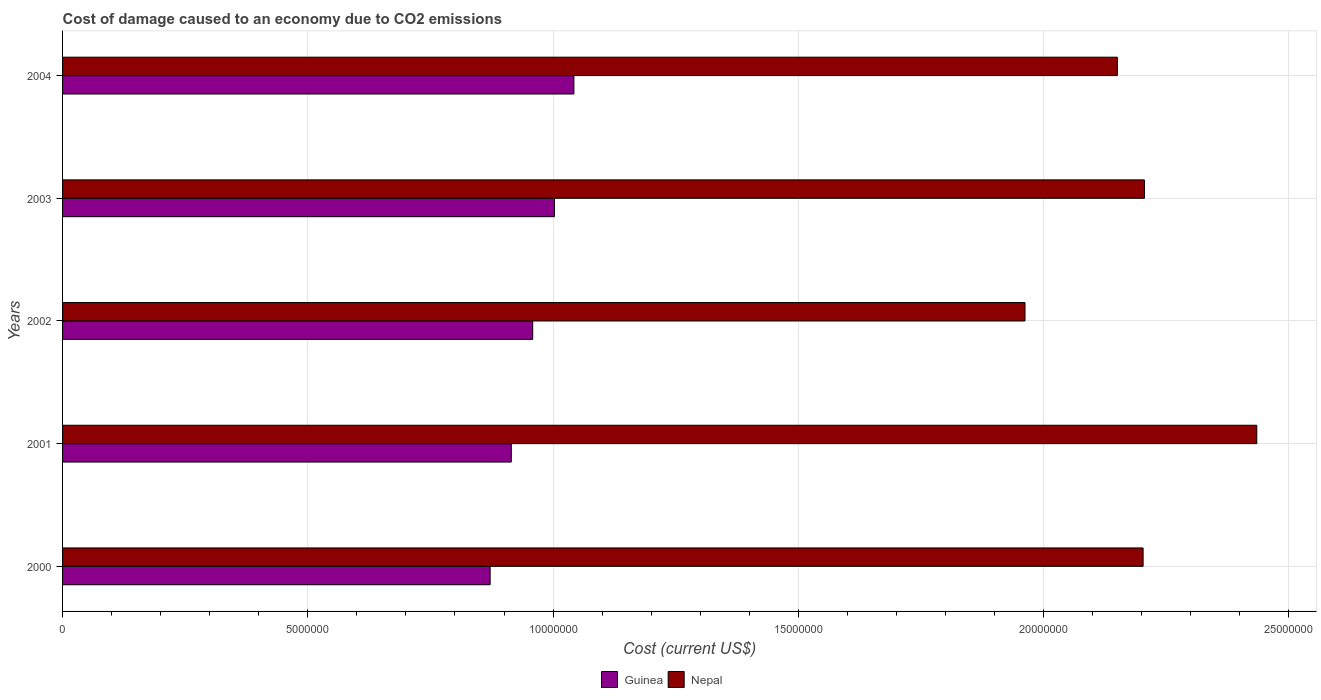How many different coloured bars are there?
Provide a succinct answer. 2. How many groups of bars are there?
Your answer should be very brief. 5. How many bars are there on the 2nd tick from the top?
Your response must be concise. 2. What is the label of the 2nd group of bars from the top?
Give a very brief answer. 2003. What is the cost of damage caused due to CO2 emissisons in Nepal in 2004?
Make the answer very short. 2.15e+07. Across all years, what is the maximum cost of damage caused due to CO2 emissisons in Nepal?
Provide a succinct answer. 2.43e+07. Across all years, what is the minimum cost of damage caused due to CO2 emissisons in Nepal?
Your answer should be compact. 1.96e+07. In which year was the cost of damage caused due to CO2 emissisons in Guinea maximum?
Your response must be concise. 2004. In which year was the cost of damage caused due to CO2 emissisons in Guinea minimum?
Your answer should be very brief. 2000. What is the total cost of damage caused due to CO2 emissisons in Nepal in the graph?
Keep it short and to the point. 1.10e+08. What is the difference between the cost of damage caused due to CO2 emissisons in Guinea in 2002 and that in 2004?
Offer a terse response. -8.40e+05. What is the difference between the cost of damage caused due to CO2 emissisons in Guinea in 2000 and the cost of damage caused due to CO2 emissisons in Nepal in 2001?
Your response must be concise. -1.56e+07. What is the average cost of damage caused due to CO2 emissisons in Nepal per year?
Keep it short and to the point. 2.19e+07. In the year 2002, what is the difference between the cost of damage caused due to CO2 emissisons in Guinea and cost of damage caused due to CO2 emissisons in Nepal?
Keep it short and to the point. -1.00e+07. In how many years, is the cost of damage caused due to CO2 emissisons in Nepal greater than 13000000 US$?
Ensure brevity in your answer.  5. What is the ratio of the cost of damage caused due to CO2 emissisons in Guinea in 2001 to that in 2004?
Your answer should be compact. 0.88. What is the difference between the highest and the second highest cost of damage caused due to CO2 emissisons in Guinea?
Make the answer very short. 3.97e+05. What is the difference between the highest and the lowest cost of damage caused due to CO2 emissisons in Guinea?
Offer a terse response. 1.71e+06. What does the 1st bar from the top in 2002 represents?
Provide a short and direct response. Nepal. What does the 2nd bar from the bottom in 2001 represents?
Your response must be concise. Nepal. Are all the bars in the graph horizontal?
Make the answer very short. Yes. What is the difference between two consecutive major ticks on the X-axis?
Make the answer very short. 5.00e+06. Are the values on the major ticks of X-axis written in scientific E-notation?
Your answer should be very brief. No. Does the graph contain any zero values?
Give a very brief answer. No. Where does the legend appear in the graph?
Give a very brief answer. Bottom center. What is the title of the graph?
Offer a very short reply. Cost of damage caused to an economy due to CO2 emissions. Does "Monaco" appear as one of the legend labels in the graph?
Ensure brevity in your answer.  No. What is the label or title of the X-axis?
Give a very brief answer. Cost (current US$). What is the label or title of the Y-axis?
Offer a very short reply. Years. What is the Cost (current US$) of Guinea in 2000?
Offer a very short reply. 8.72e+06. What is the Cost (current US$) in Nepal in 2000?
Your answer should be very brief. 2.20e+07. What is the Cost (current US$) in Guinea in 2001?
Make the answer very short. 9.15e+06. What is the Cost (current US$) in Nepal in 2001?
Keep it short and to the point. 2.43e+07. What is the Cost (current US$) of Guinea in 2002?
Provide a succinct answer. 9.58e+06. What is the Cost (current US$) in Nepal in 2002?
Offer a very short reply. 1.96e+07. What is the Cost (current US$) in Guinea in 2003?
Your answer should be compact. 1.00e+07. What is the Cost (current US$) of Nepal in 2003?
Ensure brevity in your answer.  2.21e+07. What is the Cost (current US$) in Guinea in 2004?
Offer a very short reply. 1.04e+07. What is the Cost (current US$) of Nepal in 2004?
Offer a very short reply. 2.15e+07. Across all years, what is the maximum Cost (current US$) of Guinea?
Offer a very short reply. 1.04e+07. Across all years, what is the maximum Cost (current US$) in Nepal?
Offer a very short reply. 2.43e+07. Across all years, what is the minimum Cost (current US$) in Guinea?
Make the answer very short. 8.72e+06. Across all years, what is the minimum Cost (current US$) of Nepal?
Your answer should be very brief. 1.96e+07. What is the total Cost (current US$) in Guinea in the graph?
Your response must be concise. 4.79e+07. What is the total Cost (current US$) of Nepal in the graph?
Your answer should be compact. 1.10e+08. What is the difference between the Cost (current US$) of Guinea in 2000 and that in 2001?
Keep it short and to the point. -4.33e+05. What is the difference between the Cost (current US$) of Nepal in 2000 and that in 2001?
Make the answer very short. -2.32e+06. What is the difference between the Cost (current US$) of Guinea in 2000 and that in 2002?
Provide a succinct answer. -8.68e+05. What is the difference between the Cost (current US$) of Nepal in 2000 and that in 2002?
Offer a terse response. 2.41e+06. What is the difference between the Cost (current US$) of Guinea in 2000 and that in 2003?
Keep it short and to the point. -1.31e+06. What is the difference between the Cost (current US$) of Nepal in 2000 and that in 2003?
Provide a succinct answer. -2.67e+04. What is the difference between the Cost (current US$) in Guinea in 2000 and that in 2004?
Give a very brief answer. -1.71e+06. What is the difference between the Cost (current US$) of Nepal in 2000 and that in 2004?
Make the answer very short. 5.25e+05. What is the difference between the Cost (current US$) of Guinea in 2001 and that in 2002?
Give a very brief answer. -4.36e+05. What is the difference between the Cost (current US$) in Nepal in 2001 and that in 2002?
Keep it short and to the point. 4.73e+06. What is the difference between the Cost (current US$) of Guinea in 2001 and that in 2003?
Make the answer very short. -8.79e+05. What is the difference between the Cost (current US$) of Nepal in 2001 and that in 2003?
Keep it short and to the point. 2.29e+06. What is the difference between the Cost (current US$) in Guinea in 2001 and that in 2004?
Make the answer very short. -1.28e+06. What is the difference between the Cost (current US$) of Nepal in 2001 and that in 2004?
Your answer should be compact. 2.84e+06. What is the difference between the Cost (current US$) of Guinea in 2002 and that in 2003?
Offer a very short reply. -4.43e+05. What is the difference between the Cost (current US$) in Nepal in 2002 and that in 2003?
Your answer should be very brief. -2.43e+06. What is the difference between the Cost (current US$) in Guinea in 2002 and that in 2004?
Offer a terse response. -8.40e+05. What is the difference between the Cost (current US$) in Nepal in 2002 and that in 2004?
Offer a very short reply. -1.88e+06. What is the difference between the Cost (current US$) of Guinea in 2003 and that in 2004?
Provide a short and direct response. -3.97e+05. What is the difference between the Cost (current US$) of Nepal in 2003 and that in 2004?
Give a very brief answer. 5.52e+05. What is the difference between the Cost (current US$) in Guinea in 2000 and the Cost (current US$) in Nepal in 2001?
Your answer should be compact. -1.56e+07. What is the difference between the Cost (current US$) of Guinea in 2000 and the Cost (current US$) of Nepal in 2002?
Give a very brief answer. -1.09e+07. What is the difference between the Cost (current US$) in Guinea in 2000 and the Cost (current US$) in Nepal in 2003?
Ensure brevity in your answer.  -1.33e+07. What is the difference between the Cost (current US$) in Guinea in 2000 and the Cost (current US$) in Nepal in 2004?
Your answer should be very brief. -1.28e+07. What is the difference between the Cost (current US$) of Guinea in 2001 and the Cost (current US$) of Nepal in 2002?
Provide a short and direct response. -1.05e+07. What is the difference between the Cost (current US$) in Guinea in 2001 and the Cost (current US$) in Nepal in 2003?
Your answer should be very brief. -1.29e+07. What is the difference between the Cost (current US$) in Guinea in 2001 and the Cost (current US$) in Nepal in 2004?
Keep it short and to the point. -1.24e+07. What is the difference between the Cost (current US$) in Guinea in 2002 and the Cost (current US$) in Nepal in 2003?
Give a very brief answer. -1.25e+07. What is the difference between the Cost (current US$) of Guinea in 2002 and the Cost (current US$) of Nepal in 2004?
Ensure brevity in your answer.  -1.19e+07. What is the difference between the Cost (current US$) of Guinea in 2003 and the Cost (current US$) of Nepal in 2004?
Provide a succinct answer. -1.15e+07. What is the average Cost (current US$) in Guinea per year?
Ensure brevity in your answer.  9.58e+06. What is the average Cost (current US$) in Nepal per year?
Offer a very short reply. 2.19e+07. In the year 2000, what is the difference between the Cost (current US$) in Guinea and Cost (current US$) in Nepal?
Provide a short and direct response. -1.33e+07. In the year 2001, what is the difference between the Cost (current US$) in Guinea and Cost (current US$) in Nepal?
Offer a terse response. -1.52e+07. In the year 2002, what is the difference between the Cost (current US$) of Guinea and Cost (current US$) of Nepal?
Provide a short and direct response. -1.00e+07. In the year 2003, what is the difference between the Cost (current US$) in Guinea and Cost (current US$) in Nepal?
Your answer should be compact. -1.20e+07. In the year 2004, what is the difference between the Cost (current US$) in Guinea and Cost (current US$) in Nepal?
Offer a very short reply. -1.11e+07. What is the ratio of the Cost (current US$) of Guinea in 2000 to that in 2001?
Make the answer very short. 0.95. What is the ratio of the Cost (current US$) in Nepal in 2000 to that in 2001?
Offer a very short reply. 0.9. What is the ratio of the Cost (current US$) of Guinea in 2000 to that in 2002?
Provide a short and direct response. 0.91. What is the ratio of the Cost (current US$) in Nepal in 2000 to that in 2002?
Ensure brevity in your answer.  1.12. What is the ratio of the Cost (current US$) in Guinea in 2000 to that in 2003?
Keep it short and to the point. 0.87. What is the ratio of the Cost (current US$) of Nepal in 2000 to that in 2003?
Offer a very short reply. 1. What is the ratio of the Cost (current US$) in Guinea in 2000 to that in 2004?
Your answer should be compact. 0.84. What is the ratio of the Cost (current US$) of Nepal in 2000 to that in 2004?
Provide a succinct answer. 1.02. What is the ratio of the Cost (current US$) of Guinea in 2001 to that in 2002?
Offer a very short reply. 0.95. What is the ratio of the Cost (current US$) of Nepal in 2001 to that in 2002?
Ensure brevity in your answer.  1.24. What is the ratio of the Cost (current US$) of Guinea in 2001 to that in 2003?
Provide a short and direct response. 0.91. What is the ratio of the Cost (current US$) of Nepal in 2001 to that in 2003?
Make the answer very short. 1.1. What is the ratio of the Cost (current US$) in Guinea in 2001 to that in 2004?
Keep it short and to the point. 0.88. What is the ratio of the Cost (current US$) in Nepal in 2001 to that in 2004?
Your response must be concise. 1.13. What is the ratio of the Cost (current US$) in Guinea in 2002 to that in 2003?
Your answer should be compact. 0.96. What is the ratio of the Cost (current US$) of Nepal in 2002 to that in 2003?
Provide a succinct answer. 0.89. What is the ratio of the Cost (current US$) of Guinea in 2002 to that in 2004?
Give a very brief answer. 0.92. What is the ratio of the Cost (current US$) of Nepal in 2002 to that in 2004?
Offer a terse response. 0.91. What is the ratio of the Cost (current US$) in Guinea in 2003 to that in 2004?
Give a very brief answer. 0.96. What is the ratio of the Cost (current US$) of Nepal in 2003 to that in 2004?
Provide a short and direct response. 1.03. What is the difference between the highest and the second highest Cost (current US$) of Guinea?
Give a very brief answer. 3.97e+05. What is the difference between the highest and the second highest Cost (current US$) in Nepal?
Provide a short and direct response. 2.29e+06. What is the difference between the highest and the lowest Cost (current US$) in Guinea?
Provide a short and direct response. 1.71e+06. What is the difference between the highest and the lowest Cost (current US$) in Nepal?
Make the answer very short. 4.73e+06. 